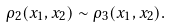<formula> <loc_0><loc_0><loc_500><loc_500>\rho _ { 2 } ( x _ { 1 } , x _ { 2 } ) \sim \rho _ { 3 } ( x _ { 1 } , x _ { 2 } ) .</formula> 